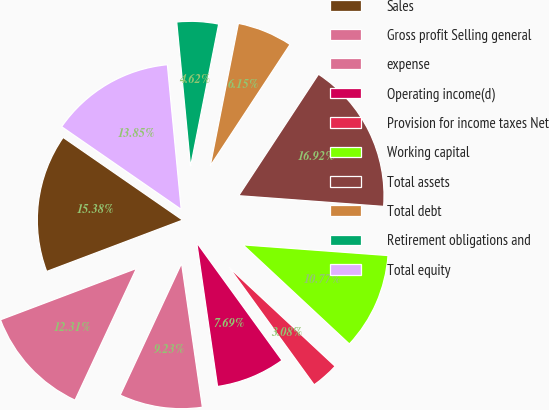Convert chart. <chart><loc_0><loc_0><loc_500><loc_500><pie_chart><fcel>Sales<fcel>Gross profit Selling general<fcel>expense<fcel>Operating income(d)<fcel>Provision for income taxes Net<fcel>Working capital<fcel>Total assets<fcel>Total debt<fcel>Retirement obligations and<fcel>Total equity<nl><fcel>15.38%<fcel>12.31%<fcel>9.23%<fcel>7.69%<fcel>3.08%<fcel>10.77%<fcel>16.92%<fcel>6.15%<fcel>4.62%<fcel>13.85%<nl></chart> 